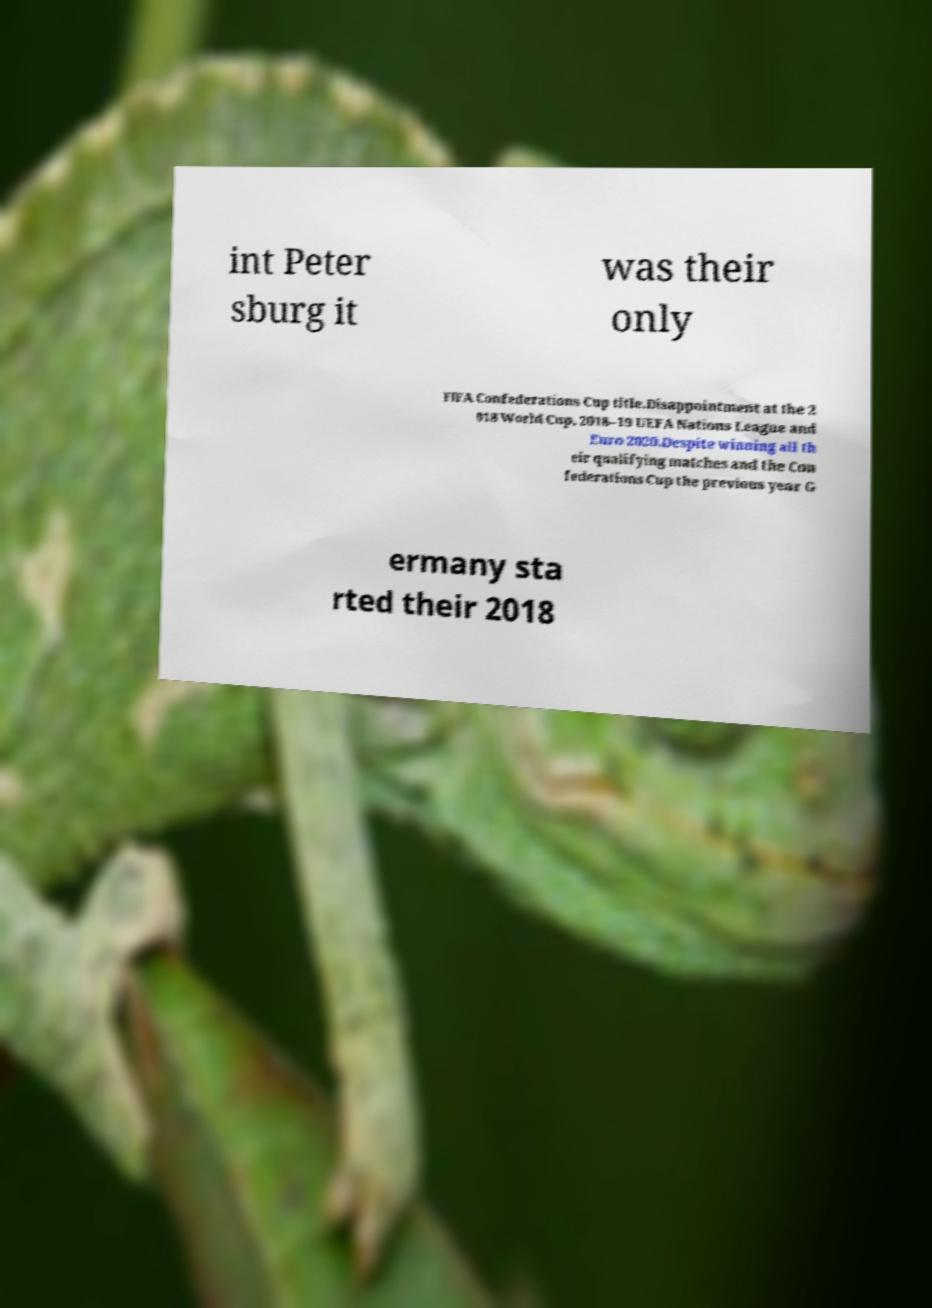What messages or text are displayed in this image? I need them in a readable, typed format. int Peter sburg it was their only FIFA Confederations Cup title.Disappointment at the 2 018 World Cup, 2018–19 UEFA Nations League and Euro 2020.Despite winning all th eir qualifying matches and the Con federations Cup the previous year G ermany sta rted their 2018 